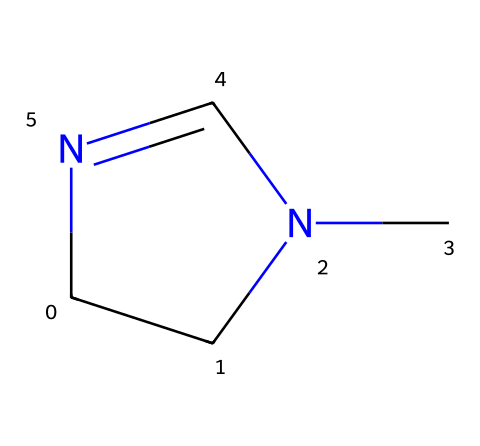What is the total number of atoms in this compound? Counting the atoms in the SMILES representation C1CN(C)C=N1, we identify 5 atoms: 2 carbon (C) from the ring, 2 nitrogen (N) (one in the ring and one in the imine), and 1 carbon (C) from the attached methyl group.
Answer: 5 How many nitrogen atoms are present in this chemical? Reviewing the structure, we can see that there are 2 nitrogen (N) atoms in the compound, one in the cyclic part and one in the imine group.
Answer: 2 What type of ring structure is present in this compound? The term "C1" in the SMILES notation indicates the beginning of a cyclic structure, and the overall arrangement shows a 5-membered ring due to the presence of two nitrogen atoms and three carbon atoms forming the cycle.
Answer: 5-membered What is the hybridization of the nitrogen atom in the imine group? The nitrogen atom in the imine part of the compound is connected to a double bond with carbon (C=N) and has one lone pair, indicating that it adopts sp2 hybridization.
Answer: sp2 Does this compound contain any chiral centers? Looking at the structure, the carbon atoms are not bound to four distinct groups, and the presence of symmetry indicates there are no chiral centers in this compound.
Answer: No What is the primary functional group in this compound? The double bond between carbon and nitrogen (C=N) signifies that the primary functional group present in this compound is an imine.
Answer: imine How does the presence of nitrogen atoms affect the stability of the cyclic structure? The presence of nitrogen can introduce lone pairs that enhance resonance and contribute to aromatic stabilization, depending on the nature of substituents, while also affecting the ring strain involving the 5-membered structure.
Answer: Increases stability 